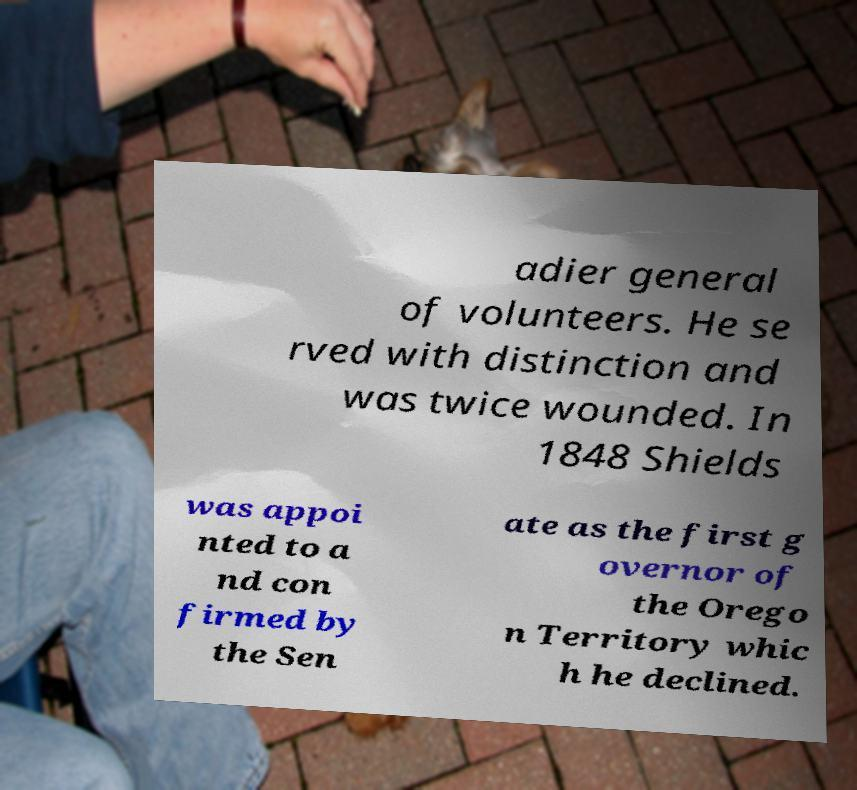Could you extract and type out the text from this image? adier general of volunteers. He se rved with distinction and was twice wounded. In 1848 Shields was appoi nted to a nd con firmed by the Sen ate as the first g overnor of the Orego n Territory whic h he declined. 